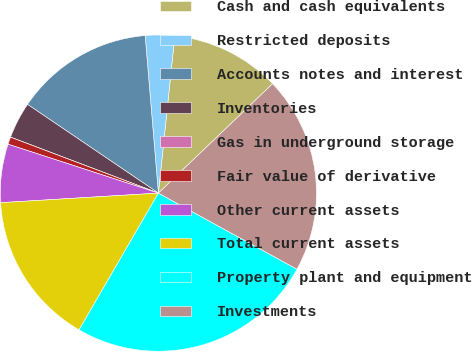<chart> <loc_0><loc_0><loc_500><loc_500><pie_chart><fcel>Cash and cash equivalents<fcel>Restricted deposits<fcel>Accounts notes and interest<fcel>Inventories<fcel>Gas in underground storage<fcel>Fair value of derivative<fcel>Other current assets<fcel>Total current assets<fcel>Property plant and equipment<fcel>Investments<nl><fcel>11.19%<fcel>2.99%<fcel>14.18%<fcel>3.73%<fcel>0.0%<fcel>0.75%<fcel>5.97%<fcel>15.67%<fcel>25.37%<fcel>20.15%<nl></chart> 